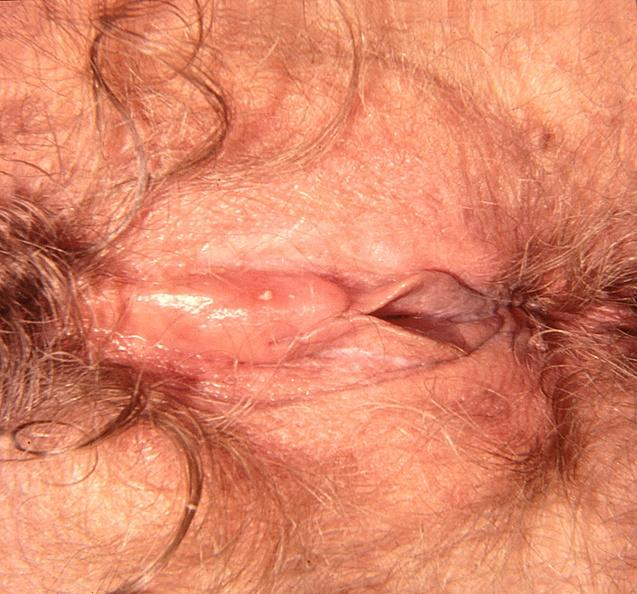does feet show vaginal herpes?
Answer the question using a single word or phrase. No 